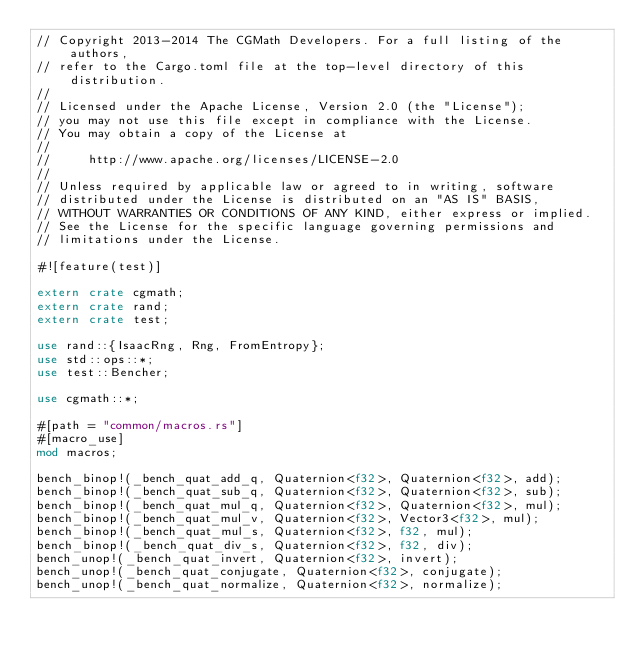Convert code to text. <code><loc_0><loc_0><loc_500><loc_500><_Rust_>// Copyright 2013-2014 The CGMath Developers. For a full listing of the authors,
// refer to the Cargo.toml file at the top-level directory of this distribution.
//
// Licensed under the Apache License, Version 2.0 (the "License");
// you may not use this file except in compliance with the License.
// You may obtain a copy of the License at
//
//     http://www.apache.org/licenses/LICENSE-2.0
//
// Unless required by applicable law or agreed to in writing, software
// distributed under the License is distributed on an "AS IS" BASIS,
// WITHOUT WARRANTIES OR CONDITIONS OF ANY KIND, either express or implied.
// See the License for the specific language governing permissions and
// limitations under the License.

#![feature(test)]

extern crate cgmath;
extern crate rand;
extern crate test;

use rand::{IsaacRng, Rng, FromEntropy};
use std::ops::*;
use test::Bencher;

use cgmath::*;

#[path = "common/macros.rs"]
#[macro_use]
mod macros;

bench_binop!(_bench_quat_add_q, Quaternion<f32>, Quaternion<f32>, add);
bench_binop!(_bench_quat_sub_q, Quaternion<f32>, Quaternion<f32>, sub);
bench_binop!(_bench_quat_mul_q, Quaternion<f32>, Quaternion<f32>, mul);
bench_binop!(_bench_quat_mul_v, Quaternion<f32>, Vector3<f32>, mul);
bench_binop!(_bench_quat_mul_s, Quaternion<f32>, f32, mul);
bench_binop!(_bench_quat_div_s, Quaternion<f32>, f32, div);
bench_unop!(_bench_quat_invert, Quaternion<f32>, invert);
bench_unop!(_bench_quat_conjugate, Quaternion<f32>, conjugate);
bench_unop!(_bench_quat_normalize, Quaternion<f32>, normalize);
</code> 